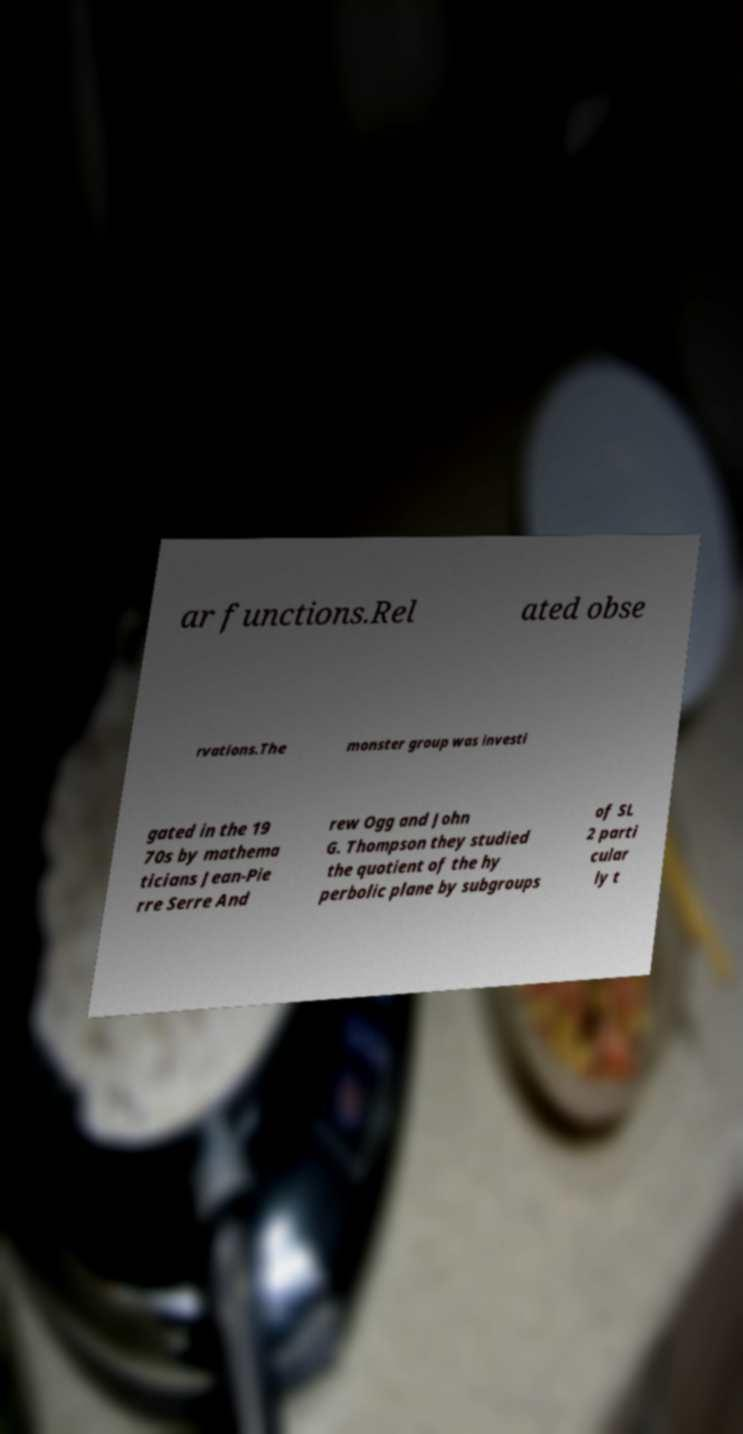There's text embedded in this image that I need extracted. Can you transcribe it verbatim? ar functions.Rel ated obse rvations.The monster group was investi gated in the 19 70s by mathema ticians Jean-Pie rre Serre And rew Ogg and John G. Thompson they studied the quotient of the hy perbolic plane by subgroups of SL 2 parti cular ly t 